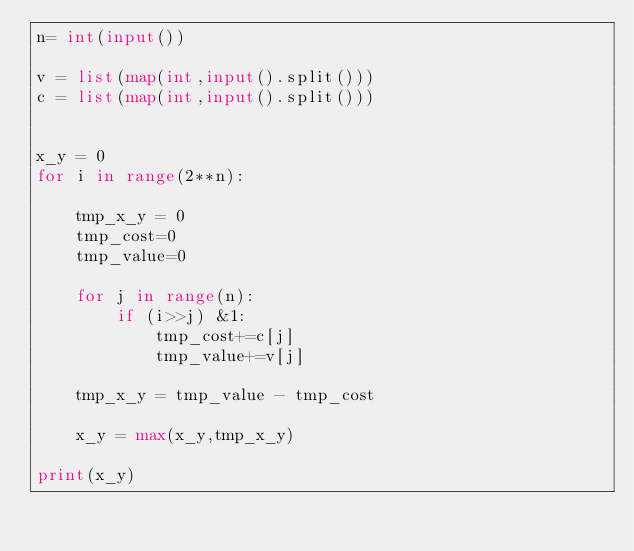Convert code to text. <code><loc_0><loc_0><loc_500><loc_500><_Python_>n= int(input())

v = list(map(int,input().split()))
c = list(map(int,input().split()))


x_y = 0
for i in range(2**n):

    tmp_x_y = 0
    tmp_cost=0
    tmp_value=0

    for j in range(n):
        if (i>>j) &1:
            tmp_cost+=c[j]
            tmp_value+=v[j]

    tmp_x_y = tmp_value - tmp_cost

    x_y = max(x_y,tmp_x_y)

print(x_y)</code> 